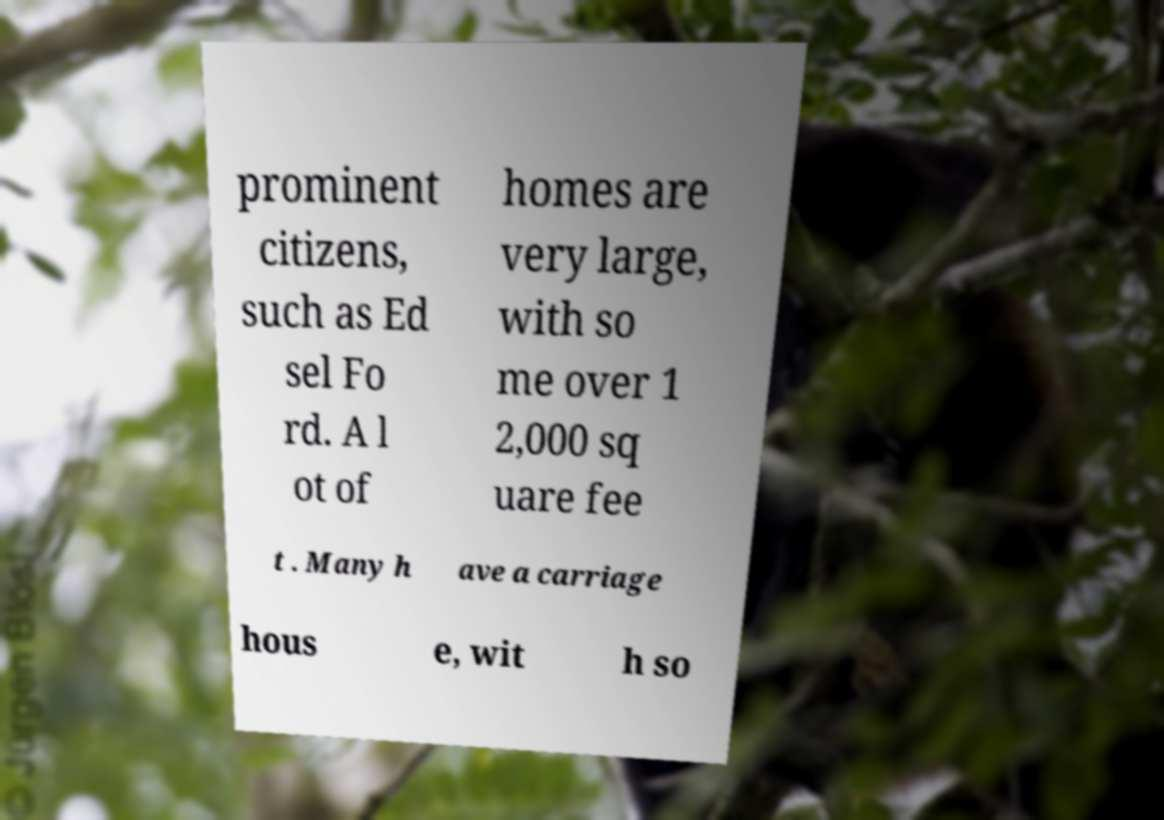I need the written content from this picture converted into text. Can you do that? prominent citizens, such as Ed sel Fo rd. A l ot of homes are very large, with so me over 1 2,000 sq uare fee t . Many h ave a carriage hous e, wit h so 